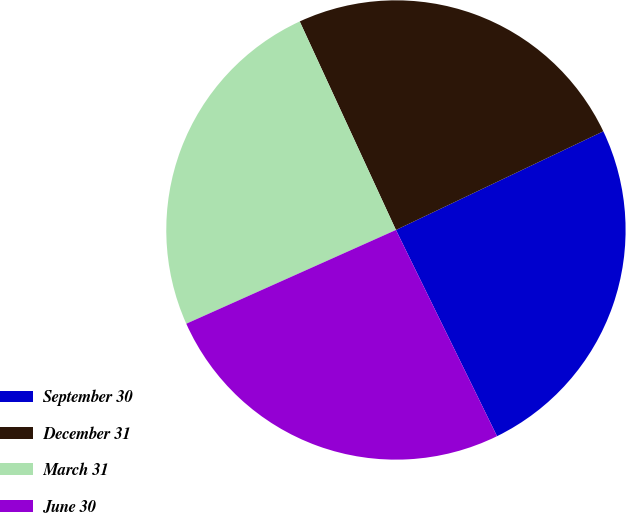Convert chart to OTSL. <chart><loc_0><loc_0><loc_500><loc_500><pie_chart><fcel>September 30<fcel>December 31<fcel>March 31<fcel>June 30<nl><fcel>24.81%<fcel>24.81%<fcel>24.81%<fcel>25.56%<nl></chart> 